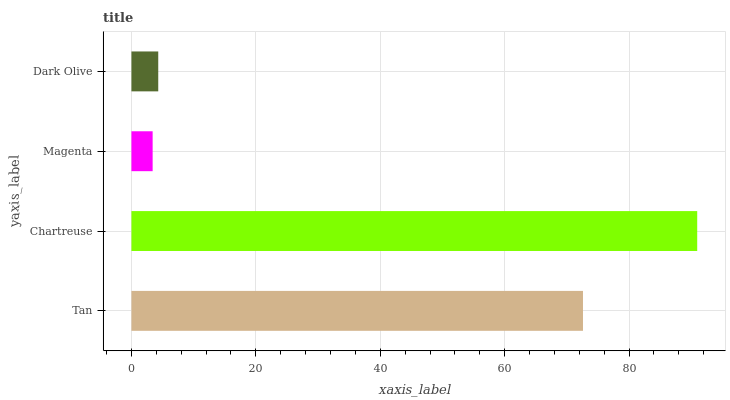Is Magenta the minimum?
Answer yes or no. Yes. Is Chartreuse the maximum?
Answer yes or no. Yes. Is Chartreuse the minimum?
Answer yes or no. No. Is Magenta the maximum?
Answer yes or no. No. Is Chartreuse greater than Magenta?
Answer yes or no. Yes. Is Magenta less than Chartreuse?
Answer yes or no. Yes. Is Magenta greater than Chartreuse?
Answer yes or no. No. Is Chartreuse less than Magenta?
Answer yes or no. No. Is Tan the high median?
Answer yes or no. Yes. Is Dark Olive the low median?
Answer yes or no. Yes. Is Chartreuse the high median?
Answer yes or no. No. Is Chartreuse the low median?
Answer yes or no. No. 